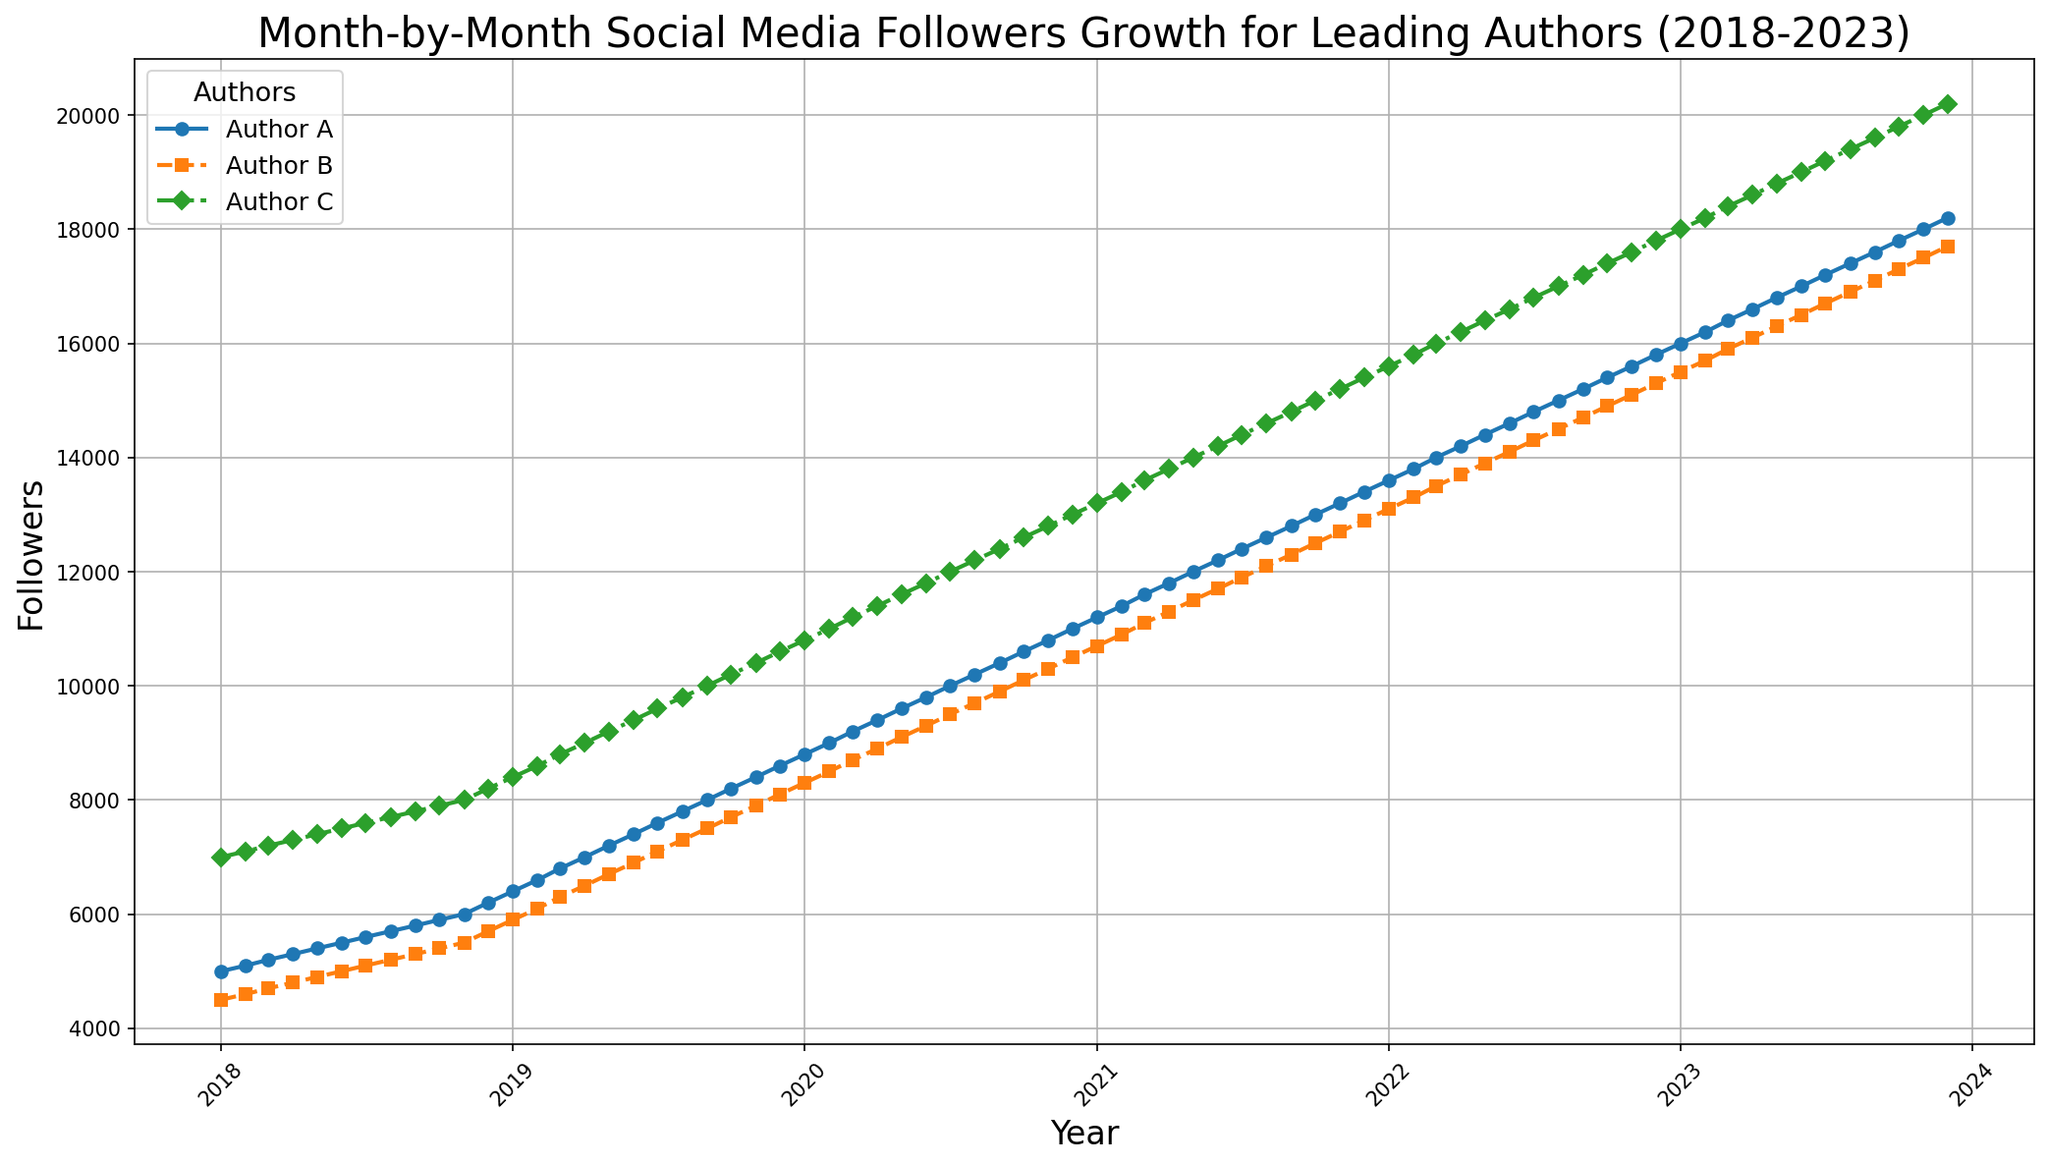What is the difference in the number of followers between Author A and Author C in December 2023? To find the difference in the number of followers between Author A and Author C in December 2023, look at the data points on the chart for that month for each author. Author A has 18,200 followers, and Author C has 20,200 followers. Subtract the followers of Author A from Author C: 20,200 - 18,200 = 2,000.
Answer: 2,000 Which author had the highest growth rate in followers during the year 2023? To determine the highest growth rate, compare the increase in followers from January 2023 to December 2023 for each author. Author A's followers increased from 16,000 to 18,200 (2,200), Author B's from 15,500 to 17,700 (2,200), and Author C's from 18,000 to 20,200 (2,200). All authors had the same growth rate in 2023.
Answer: All authors had the same growth rate Which author had the largest overall followers count in November 2023? Look at the data points for November 2023 for each author. The followers count is: Author A (18,000), Author B (17,500), and Author C (20,000). Author C has the highest number of followers.
Answer: Author C Which author had more followers in December 2022, Author A or Author B, and by how many? Check the followers count for December 2022: Author A has 15,800 followers, and Author B has 15,300 followers. Subtract Author B's followers from Author A's followers: 15,800 - 15,300 = 500. Author A has 500 more followers than Author B.
Answer: Author A, by 500 What visual differences can you observe in the trends of Author A and Author B's follower counts over the last five years? Observe the patterns and slope of the lines representing Author A and Author B. Author A shows a steady and consistent upward trend without any significant fluctuations, represented by a smooth line. Author B also shows an upward trend but with slightly sharper increases and more noticeable steps in follower count, indicated by more pronounced upward jumps at intervals.
Answer: Steady vs stepped increases From which year did Author C's followers count surpass 15,000? Look at the trend line for Author C and identify the point where the follower count crosses 15,000. This point occurs in January 2022.
Answer: January 2022 How does the total number of followers gained by Author B from 2018 to 2023 compare to Author A over the same period? Calculate the total increase for each author by subtracting the followers count at the start of 2018 from the count at the end of 2023. For Author B: 17,700 (December 2023) - 4,500 (January 2018) = 13,200. For Author A: 18,200 (December 2023) - 5,000 (January 2018) = 13,200. The gains are equal.
Answer: Equal gains Which author showed the most rapid increase in followers during any single month, and when was it? Look for the steepest jump in the follower count graph for any author over a month. During May 2018, Author B's follower count rose noticeably more than in other months. Check the numerical data to confirm: Author B's followers went from 4,900 in May to 5,700 in June, an increase of 800, which is significant.
Answer: Author B, May 2018 How much did Author A's followers increase from July to December 2020? Look at the data points for July 2020 and December 2020 for Author A: 10,000 in July and 11,000 in December. Subtract July's followers from December's: 11,000 - 10,000 = 1,000.
Answer: 1,000 